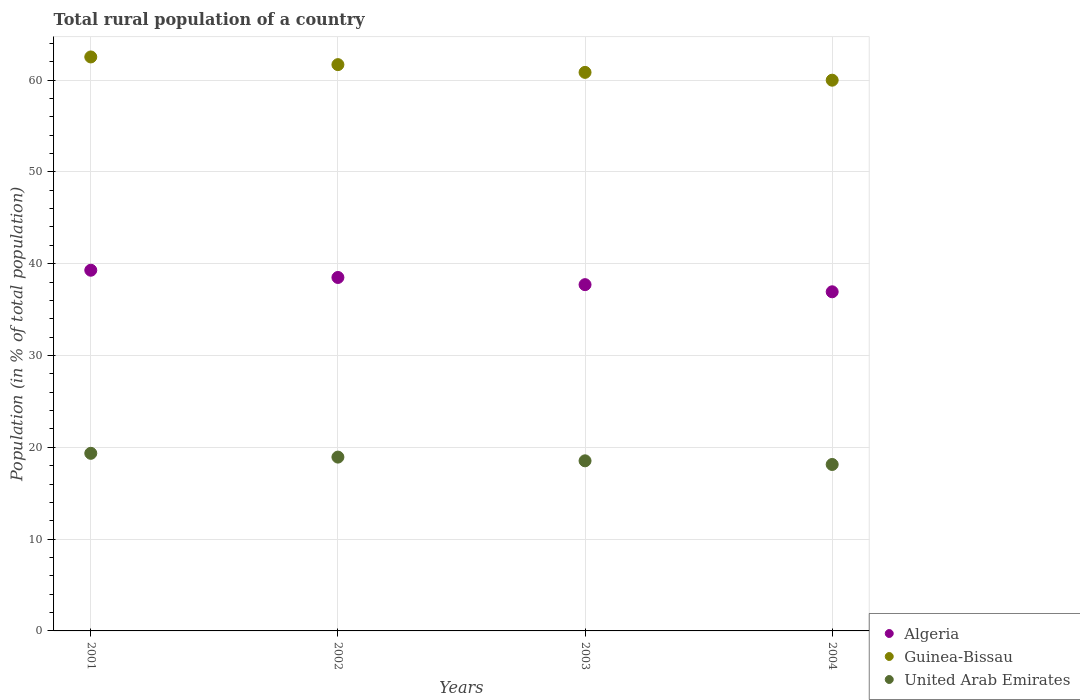How many different coloured dotlines are there?
Make the answer very short. 3. Is the number of dotlines equal to the number of legend labels?
Provide a short and direct response. Yes. What is the rural population in United Arab Emirates in 2001?
Provide a short and direct response. 19.34. Across all years, what is the maximum rural population in Guinea-Bissau?
Ensure brevity in your answer.  62.52. Across all years, what is the minimum rural population in United Arab Emirates?
Provide a succinct answer. 18.13. In which year was the rural population in Guinea-Bissau minimum?
Ensure brevity in your answer.  2004. What is the total rural population in Algeria in the graph?
Provide a succinct answer. 152.44. What is the difference between the rural population in Guinea-Bissau in 2001 and that in 2003?
Give a very brief answer. 1.68. What is the difference between the rural population in Guinea-Bissau in 2003 and the rural population in United Arab Emirates in 2001?
Provide a short and direct response. 41.49. What is the average rural population in Algeria per year?
Give a very brief answer. 38.11. In the year 2002, what is the difference between the rural population in Guinea-Bissau and rural population in Algeria?
Your response must be concise. 23.18. In how many years, is the rural population in Guinea-Bissau greater than 36 %?
Give a very brief answer. 4. What is the ratio of the rural population in Algeria in 2003 to that in 2004?
Ensure brevity in your answer.  1.02. Is the difference between the rural population in Guinea-Bissau in 2003 and 2004 greater than the difference between the rural population in Algeria in 2003 and 2004?
Provide a succinct answer. Yes. What is the difference between the highest and the second highest rural population in Guinea-Bissau?
Your response must be concise. 0.84. What is the difference between the highest and the lowest rural population in Guinea-Bissau?
Your answer should be compact. 2.53. Does the rural population in Guinea-Bissau monotonically increase over the years?
Keep it short and to the point. No. Is the rural population in Guinea-Bissau strictly greater than the rural population in United Arab Emirates over the years?
Ensure brevity in your answer.  Yes. How many years are there in the graph?
Your answer should be compact. 4. What is the difference between two consecutive major ticks on the Y-axis?
Offer a terse response. 10. Does the graph contain any zero values?
Provide a short and direct response. No. Where does the legend appear in the graph?
Your answer should be compact. Bottom right. What is the title of the graph?
Your answer should be very brief. Total rural population of a country. What is the label or title of the X-axis?
Offer a very short reply. Years. What is the label or title of the Y-axis?
Keep it short and to the point. Population (in % of total population). What is the Population (in % of total population) in Algeria in 2001?
Make the answer very short. 39.29. What is the Population (in % of total population) in Guinea-Bissau in 2001?
Offer a terse response. 62.52. What is the Population (in % of total population) of United Arab Emirates in 2001?
Offer a very short reply. 19.34. What is the Population (in % of total population) in Algeria in 2002?
Your response must be concise. 38.5. What is the Population (in % of total population) in Guinea-Bissau in 2002?
Ensure brevity in your answer.  61.68. What is the Population (in % of total population) in United Arab Emirates in 2002?
Your answer should be very brief. 18.93. What is the Population (in % of total population) in Algeria in 2003?
Make the answer very short. 37.72. What is the Population (in % of total population) in Guinea-Bissau in 2003?
Your answer should be very brief. 60.84. What is the Population (in % of total population) in United Arab Emirates in 2003?
Keep it short and to the point. 18.53. What is the Population (in % of total population) of Algeria in 2004?
Provide a short and direct response. 36.94. What is the Population (in % of total population) of Guinea-Bissau in 2004?
Offer a very short reply. 59.99. What is the Population (in % of total population) in United Arab Emirates in 2004?
Your answer should be compact. 18.13. Across all years, what is the maximum Population (in % of total population) in Algeria?
Keep it short and to the point. 39.29. Across all years, what is the maximum Population (in % of total population) of Guinea-Bissau?
Provide a short and direct response. 62.52. Across all years, what is the maximum Population (in % of total population) in United Arab Emirates?
Make the answer very short. 19.34. Across all years, what is the minimum Population (in % of total population) in Algeria?
Provide a succinct answer. 36.94. Across all years, what is the minimum Population (in % of total population) in Guinea-Bissau?
Your response must be concise. 59.99. Across all years, what is the minimum Population (in % of total population) in United Arab Emirates?
Provide a short and direct response. 18.13. What is the total Population (in % of total population) of Algeria in the graph?
Ensure brevity in your answer.  152.44. What is the total Population (in % of total population) of Guinea-Bissau in the graph?
Your answer should be very brief. 245.03. What is the total Population (in % of total population) in United Arab Emirates in the graph?
Offer a very short reply. 74.94. What is the difference between the Population (in % of total population) in Algeria in 2001 and that in 2002?
Give a very brief answer. 0.79. What is the difference between the Population (in % of total population) in Guinea-Bissau in 2001 and that in 2002?
Your answer should be very brief. 0.84. What is the difference between the Population (in % of total population) in United Arab Emirates in 2001 and that in 2002?
Provide a succinct answer. 0.41. What is the difference between the Population (in % of total population) in Algeria in 2001 and that in 2003?
Your answer should be very brief. 1.57. What is the difference between the Population (in % of total population) of Guinea-Bissau in 2001 and that in 2003?
Your response must be concise. 1.68. What is the difference between the Population (in % of total population) in United Arab Emirates in 2001 and that in 2003?
Your response must be concise. 0.82. What is the difference between the Population (in % of total population) in Algeria in 2001 and that in 2004?
Make the answer very short. 2.35. What is the difference between the Population (in % of total population) in Guinea-Bissau in 2001 and that in 2004?
Make the answer very short. 2.53. What is the difference between the Population (in % of total population) of United Arab Emirates in 2001 and that in 2004?
Offer a very short reply. 1.22. What is the difference between the Population (in % of total population) of Algeria in 2002 and that in 2003?
Ensure brevity in your answer.  0.78. What is the difference between the Population (in % of total population) of Guinea-Bissau in 2002 and that in 2003?
Provide a succinct answer. 0.84. What is the difference between the Population (in % of total population) in United Arab Emirates in 2002 and that in 2003?
Give a very brief answer. 0.41. What is the difference between the Population (in % of total population) of Algeria in 2002 and that in 2004?
Make the answer very short. 1.56. What is the difference between the Population (in % of total population) of Guinea-Bissau in 2002 and that in 2004?
Provide a succinct answer. 1.7. What is the difference between the Population (in % of total population) in United Arab Emirates in 2002 and that in 2004?
Ensure brevity in your answer.  0.8. What is the difference between the Population (in % of total population) of Algeria in 2003 and that in 2004?
Offer a very short reply. 0.78. What is the difference between the Population (in % of total population) in Guinea-Bissau in 2003 and that in 2004?
Your answer should be compact. 0.85. What is the difference between the Population (in % of total population) in United Arab Emirates in 2003 and that in 2004?
Your response must be concise. 0.4. What is the difference between the Population (in % of total population) of Algeria in 2001 and the Population (in % of total population) of Guinea-Bissau in 2002?
Give a very brief answer. -22.39. What is the difference between the Population (in % of total population) in Algeria in 2001 and the Population (in % of total population) in United Arab Emirates in 2002?
Keep it short and to the point. 20.36. What is the difference between the Population (in % of total population) of Guinea-Bissau in 2001 and the Population (in % of total population) of United Arab Emirates in 2002?
Ensure brevity in your answer.  43.59. What is the difference between the Population (in % of total population) in Algeria in 2001 and the Population (in % of total population) in Guinea-Bissau in 2003?
Ensure brevity in your answer.  -21.55. What is the difference between the Population (in % of total population) in Algeria in 2001 and the Population (in % of total population) in United Arab Emirates in 2003?
Your answer should be very brief. 20.76. What is the difference between the Population (in % of total population) of Guinea-Bissau in 2001 and the Population (in % of total population) of United Arab Emirates in 2003?
Provide a short and direct response. 43.99. What is the difference between the Population (in % of total population) of Algeria in 2001 and the Population (in % of total population) of Guinea-Bissau in 2004?
Give a very brief answer. -20.7. What is the difference between the Population (in % of total population) of Algeria in 2001 and the Population (in % of total population) of United Arab Emirates in 2004?
Offer a very short reply. 21.16. What is the difference between the Population (in % of total population) of Guinea-Bissau in 2001 and the Population (in % of total population) of United Arab Emirates in 2004?
Provide a short and direct response. 44.39. What is the difference between the Population (in % of total population) of Algeria in 2002 and the Population (in % of total population) of Guinea-Bissau in 2003?
Make the answer very short. -22.34. What is the difference between the Population (in % of total population) of Algeria in 2002 and the Population (in % of total population) of United Arab Emirates in 2003?
Make the answer very short. 19.97. What is the difference between the Population (in % of total population) in Guinea-Bissau in 2002 and the Population (in % of total population) in United Arab Emirates in 2003?
Give a very brief answer. 43.15. What is the difference between the Population (in % of total population) of Algeria in 2002 and the Population (in % of total population) of Guinea-Bissau in 2004?
Give a very brief answer. -21.49. What is the difference between the Population (in % of total population) of Algeria in 2002 and the Population (in % of total population) of United Arab Emirates in 2004?
Your response must be concise. 20.37. What is the difference between the Population (in % of total population) in Guinea-Bissau in 2002 and the Population (in % of total population) in United Arab Emirates in 2004?
Your answer should be compact. 43.55. What is the difference between the Population (in % of total population) in Algeria in 2003 and the Population (in % of total population) in Guinea-Bissau in 2004?
Your answer should be compact. -22.27. What is the difference between the Population (in % of total population) in Algeria in 2003 and the Population (in % of total population) in United Arab Emirates in 2004?
Offer a very short reply. 19.59. What is the difference between the Population (in % of total population) in Guinea-Bissau in 2003 and the Population (in % of total population) in United Arab Emirates in 2004?
Your response must be concise. 42.71. What is the average Population (in % of total population) of Algeria per year?
Provide a short and direct response. 38.11. What is the average Population (in % of total population) of Guinea-Bissau per year?
Give a very brief answer. 61.26. What is the average Population (in % of total population) of United Arab Emirates per year?
Offer a terse response. 18.73. In the year 2001, what is the difference between the Population (in % of total population) in Algeria and Population (in % of total population) in Guinea-Bissau?
Keep it short and to the point. -23.23. In the year 2001, what is the difference between the Population (in % of total population) of Algeria and Population (in % of total population) of United Arab Emirates?
Your response must be concise. 19.94. In the year 2001, what is the difference between the Population (in % of total population) of Guinea-Bissau and Population (in % of total population) of United Arab Emirates?
Make the answer very short. 43.17. In the year 2002, what is the difference between the Population (in % of total population) in Algeria and Population (in % of total population) in Guinea-Bissau?
Provide a succinct answer. -23.18. In the year 2002, what is the difference between the Population (in % of total population) of Algeria and Population (in % of total population) of United Arab Emirates?
Keep it short and to the point. 19.57. In the year 2002, what is the difference between the Population (in % of total population) of Guinea-Bissau and Population (in % of total population) of United Arab Emirates?
Ensure brevity in your answer.  42.75. In the year 2003, what is the difference between the Population (in % of total population) of Algeria and Population (in % of total population) of Guinea-Bissau?
Keep it short and to the point. -23.12. In the year 2003, what is the difference between the Population (in % of total population) in Algeria and Population (in % of total population) in United Arab Emirates?
Offer a terse response. 19.19. In the year 2003, what is the difference between the Population (in % of total population) of Guinea-Bissau and Population (in % of total population) of United Arab Emirates?
Your response must be concise. 42.31. In the year 2004, what is the difference between the Population (in % of total population) in Algeria and Population (in % of total population) in Guinea-Bissau?
Give a very brief answer. -23.05. In the year 2004, what is the difference between the Population (in % of total population) in Algeria and Population (in % of total population) in United Arab Emirates?
Keep it short and to the point. 18.81. In the year 2004, what is the difference between the Population (in % of total population) of Guinea-Bissau and Population (in % of total population) of United Arab Emirates?
Your response must be concise. 41.86. What is the ratio of the Population (in % of total population) of Algeria in 2001 to that in 2002?
Your answer should be compact. 1.02. What is the ratio of the Population (in % of total population) of Guinea-Bissau in 2001 to that in 2002?
Offer a very short reply. 1.01. What is the ratio of the Population (in % of total population) in United Arab Emirates in 2001 to that in 2002?
Offer a terse response. 1.02. What is the ratio of the Population (in % of total population) of Algeria in 2001 to that in 2003?
Offer a terse response. 1.04. What is the ratio of the Population (in % of total population) of Guinea-Bissau in 2001 to that in 2003?
Your answer should be compact. 1.03. What is the ratio of the Population (in % of total population) of United Arab Emirates in 2001 to that in 2003?
Keep it short and to the point. 1.04. What is the ratio of the Population (in % of total population) in Algeria in 2001 to that in 2004?
Your response must be concise. 1.06. What is the ratio of the Population (in % of total population) of Guinea-Bissau in 2001 to that in 2004?
Offer a terse response. 1.04. What is the ratio of the Population (in % of total population) in United Arab Emirates in 2001 to that in 2004?
Offer a very short reply. 1.07. What is the ratio of the Population (in % of total population) of Algeria in 2002 to that in 2003?
Offer a terse response. 1.02. What is the ratio of the Population (in % of total population) in Guinea-Bissau in 2002 to that in 2003?
Your response must be concise. 1.01. What is the ratio of the Population (in % of total population) in United Arab Emirates in 2002 to that in 2003?
Your response must be concise. 1.02. What is the ratio of the Population (in % of total population) in Algeria in 2002 to that in 2004?
Provide a succinct answer. 1.04. What is the ratio of the Population (in % of total population) in Guinea-Bissau in 2002 to that in 2004?
Offer a very short reply. 1.03. What is the ratio of the Population (in % of total population) of United Arab Emirates in 2002 to that in 2004?
Offer a very short reply. 1.04. What is the ratio of the Population (in % of total population) in Guinea-Bissau in 2003 to that in 2004?
Provide a short and direct response. 1.01. What is the ratio of the Population (in % of total population) in United Arab Emirates in 2003 to that in 2004?
Provide a succinct answer. 1.02. What is the difference between the highest and the second highest Population (in % of total population) in Algeria?
Your answer should be very brief. 0.79. What is the difference between the highest and the second highest Population (in % of total population) in Guinea-Bissau?
Your response must be concise. 0.84. What is the difference between the highest and the second highest Population (in % of total population) in United Arab Emirates?
Your answer should be very brief. 0.41. What is the difference between the highest and the lowest Population (in % of total population) of Algeria?
Offer a terse response. 2.35. What is the difference between the highest and the lowest Population (in % of total population) of Guinea-Bissau?
Give a very brief answer. 2.53. What is the difference between the highest and the lowest Population (in % of total population) of United Arab Emirates?
Offer a terse response. 1.22. 